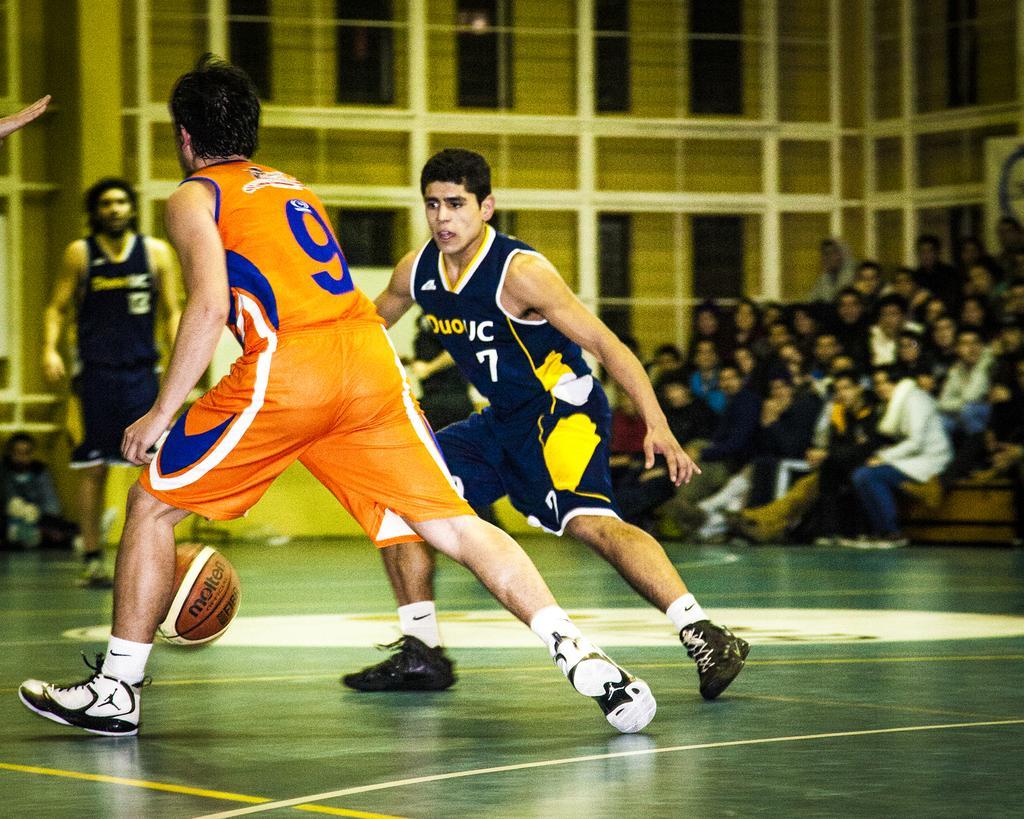Please provide a concise description of this image. In this picture there are few persons playing volleyball and there are few audience in the right corner. 